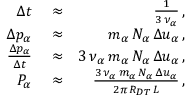Convert formula to latex. <formula><loc_0><loc_0><loc_500><loc_500>\begin{array} { r l r } { \Delta t } & \approx } & { \frac { 1 } { 3 \, \nu _ { \alpha } } \, , } \\ { \Delta p _ { \alpha } } & \approx } & { m _ { \alpha } \, N _ { \alpha } \, \Delta u _ { \alpha } \, , } \\ { \frac { \Delta p _ { \alpha } } { \Delta t } } & \approx } & { 3 \, \nu _ { \alpha } \, m _ { \alpha } \, N _ { \alpha } \, \Delta u _ { \alpha } \, , } \\ { P _ { \alpha } } & \approx } & { \frac { 3 \, \nu _ { \alpha } \, m _ { \alpha } \, N _ { \alpha } \, \Delta u _ { \alpha } } { 2 \pi \, R _ { D T } \, L } \, , } \end{array}</formula> 